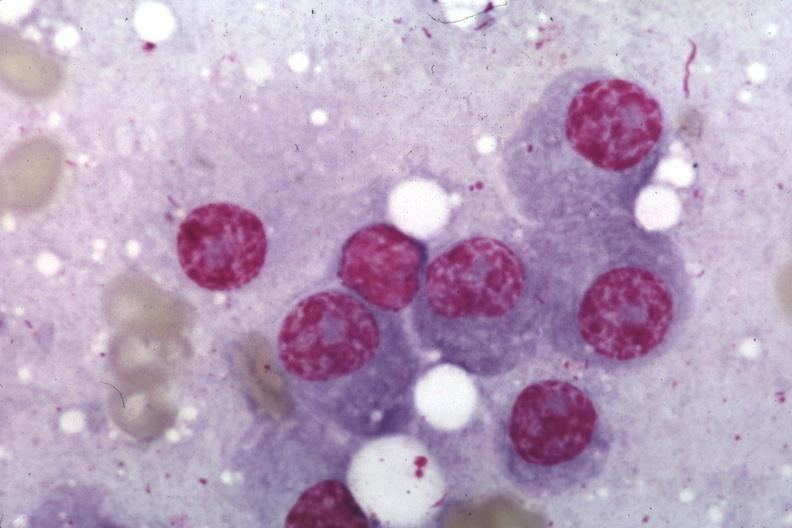what does this image show?
Answer the question using a single word or phrase. Wrights typical plasma cells 